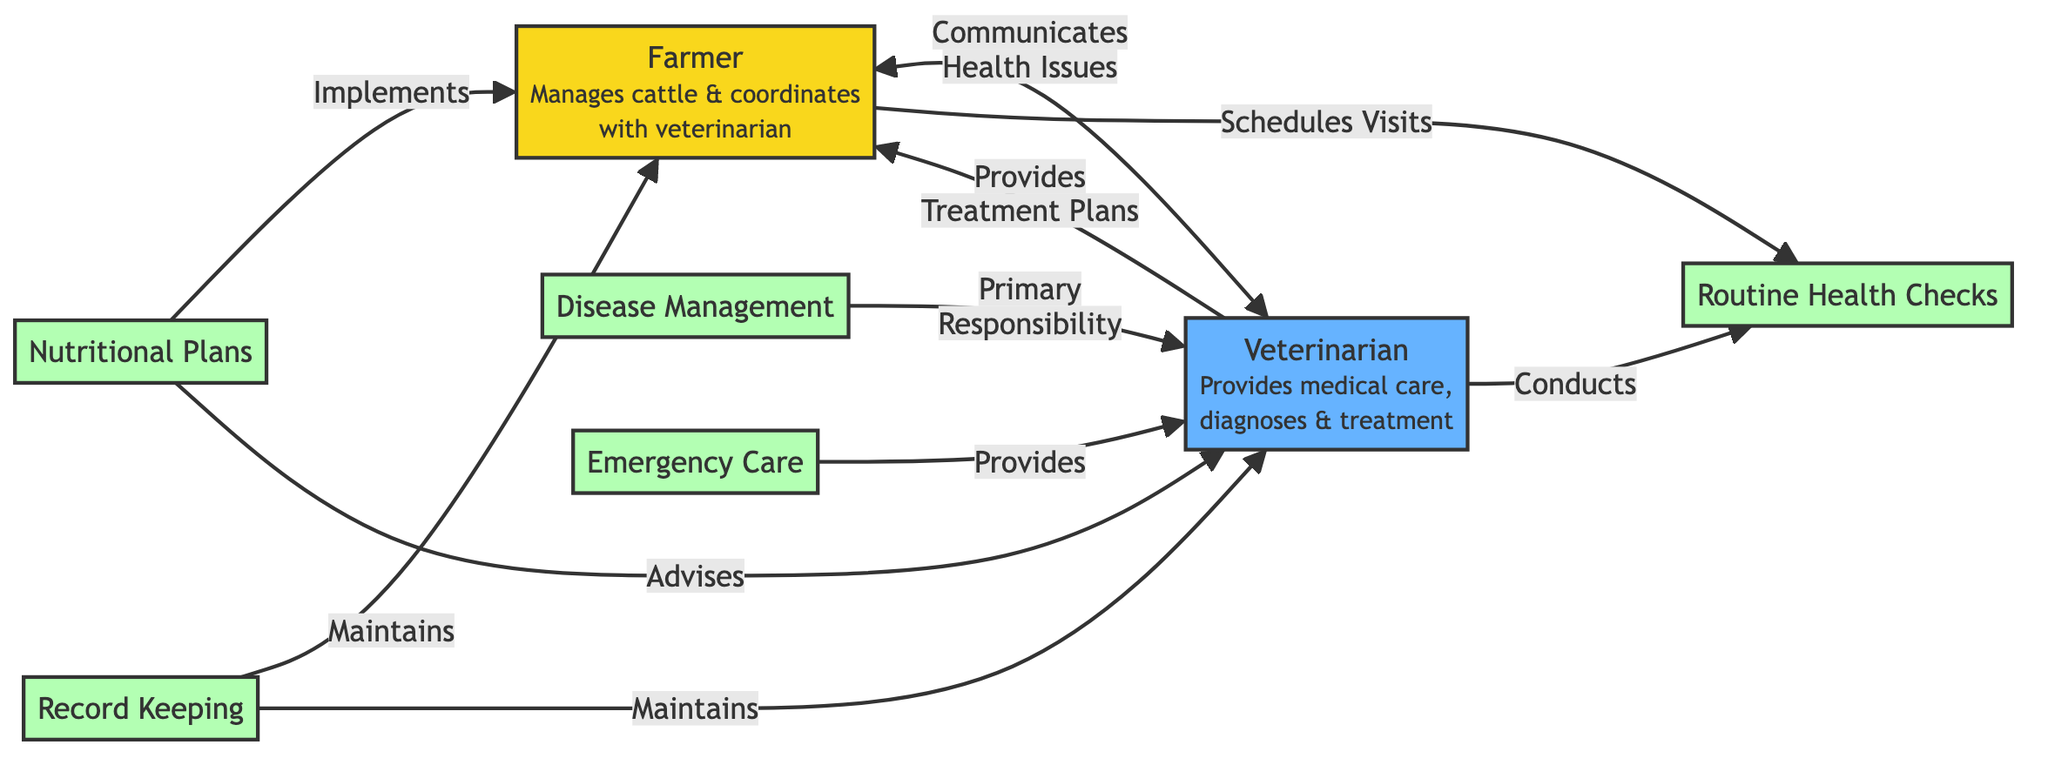What are the two main roles illustrated in this diagram? The diagram features two main roles: Farmer and Veterinarian. These roles are clearly labeled at the top of the diagram, outlining their responsibilities.
Answer: Farmer, Veterinarian How many activities are represented in the diagram? There are five activities represented: Routine Health Checks, Disease Management, Nutritional Plans, Emergency Care, and Record Keeping. Counting each labeled activity in the diagram gives us this total.
Answer: Five What type of communication does the farmer provide to the veterinarian? The communication pathway between the farmer and veterinarian indicates that the farmer communicates health issues to the veterinarian. This is specified by the labeled arrow showing their interaction.
Answer: Health Issues Who has primary responsibility for disease management? The diagram indicates that disease management is the primary responsibility of the veterinarian, as shown by the direct label next to this activity.
Answer: Veterinarian Which role is responsible for implementing nutritional plans? According to the diagram, the farmer is responsible for implementing nutritional plans, as stated in the labeled arrow that connects the farmer to this activity.
Answer: Farmer What do the arrows between the farmer and veterinarian signify? The arrows represent communication and collaboration pathways, indicating how both roles interact and share responsibilities. Specifically, one arrow shows the farmer communicating health issues, while another shows the veterinarian providing treatment plans.
Answer: Communication Which activity does the veterinarian conduct regularly? The activity that the veterinarian conducts regularly, as depicted in the diagram, is Routine Health Checks. This is connected with an arrow leading from the veterinarian to the activity.
Answer: Routine Health Checks Which two activities show shared responsibility between the farmer and veterinarian? The diagram shows shared responsibility in Record Keeping, where both roles maintain records. This is indicated by two arrows, one leading from each role to the Record Keeping activity.
Answer: Record Keeping What does the veterinarian provide in an emergency? In emergencies, the veterinarian provides emergency care, which is clearly labeled in the diagram, showing their active role during such situations.
Answer: Emergency Care 